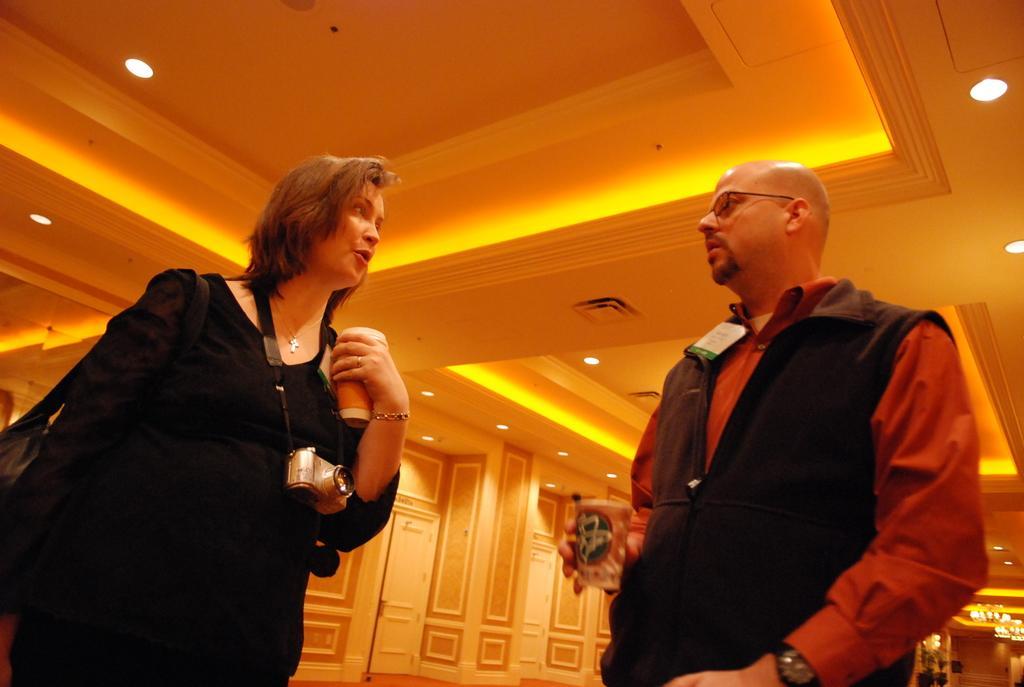How would you summarize this image in a sentence or two? In this picture there is a man wearing black color jacket and red shirt is stalking with the women wearing a black color top with camera in the neck. Behind we can see white color doors and on the top ceiling there is a spotlights. 